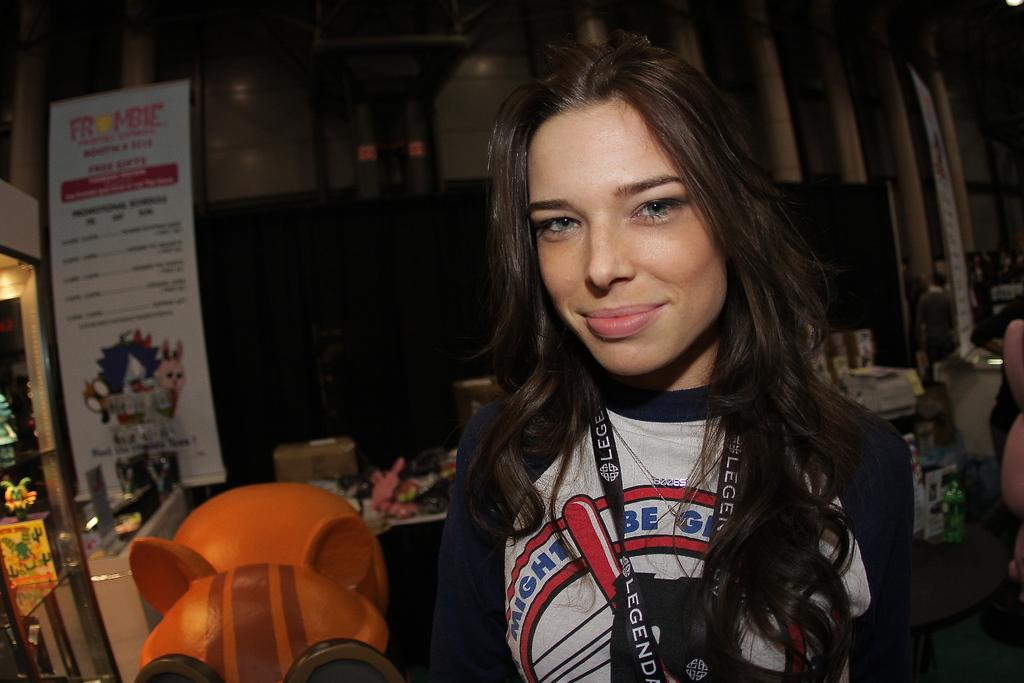<image>
Give a short and clear explanation of the subsequent image. A woman standing in a store in front of a frombie sign. 